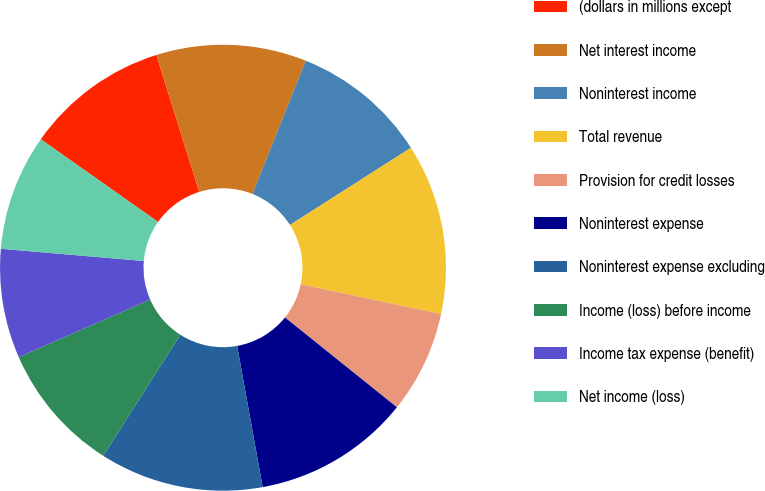<chart> <loc_0><loc_0><loc_500><loc_500><pie_chart><fcel>(dollars in millions except<fcel>Net interest income<fcel>Noninterest income<fcel>Total revenue<fcel>Provision for credit losses<fcel>Noninterest expense<fcel>Noninterest expense excluding<fcel>Income (loss) before income<fcel>Income tax expense (benefit)<fcel>Net income (loss)<nl><fcel>10.4%<fcel>10.89%<fcel>9.9%<fcel>12.38%<fcel>7.43%<fcel>11.39%<fcel>11.88%<fcel>9.41%<fcel>7.92%<fcel>8.42%<nl></chart> 